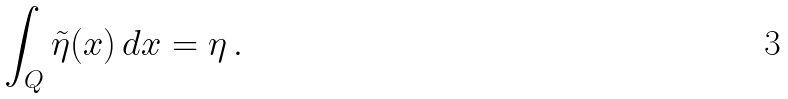<formula> <loc_0><loc_0><loc_500><loc_500>\int _ { Q } \tilde { \eta } ( x ) \, d x = \eta \, .</formula> 